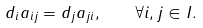<formula> <loc_0><loc_0><loc_500><loc_500>d _ { i } a _ { i j } = d _ { j } a _ { j i } , \quad \forall i , j \in I .</formula> 